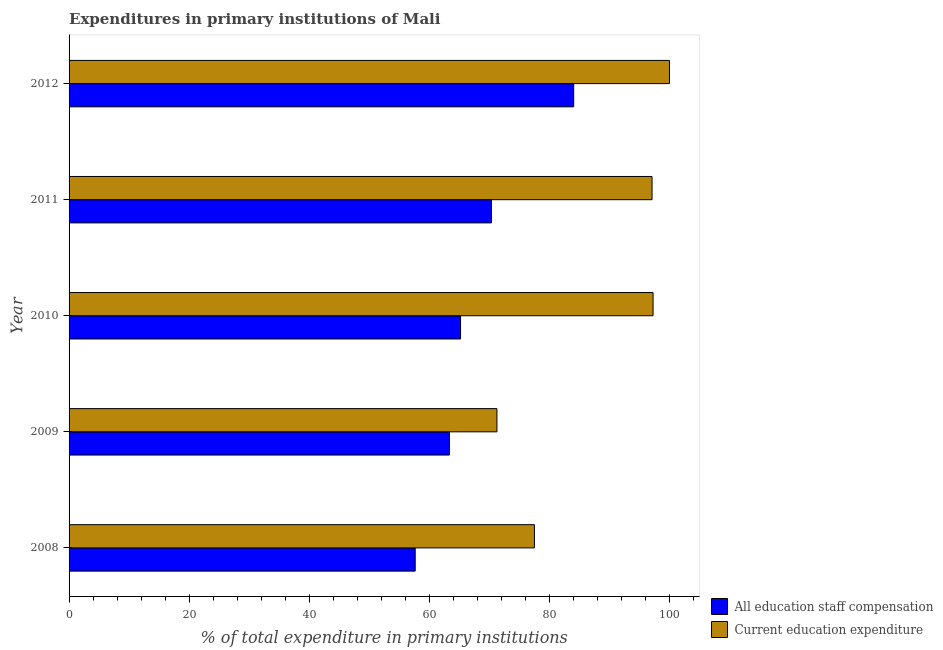How many different coloured bars are there?
Give a very brief answer. 2. How many groups of bars are there?
Ensure brevity in your answer.  5. Are the number of bars per tick equal to the number of legend labels?
Your answer should be compact. Yes. How many bars are there on the 4th tick from the top?
Give a very brief answer. 2. What is the label of the 4th group of bars from the top?
Provide a succinct answer. 2009. What is the expenditure in staff compensation in 2012?
Offer a terse response. 84.04. Across all years, what is the maximum expenditure in staff compensation?
Make the answer very short. 84.04. Across all years, what is the minimum expenditure in education?
Provide a short and direct response. 71.26. In which year was the expenditure in education maximum?
Your answer should be very brief. 2012. In which year was the expenditure in staff compensation minimum?
Provide a succinct answer. 2008. What is the total expenditure in education in the graph?
Make the answer very short. 443.12. What is the difference between the expenditure in education in 2009 and that in 2012?
Provide a short and direct response. -28.74. What is the difference between the expenditure in education in 2012 and the expenditure in staff compensation in 2010?
Your response must be concise. 34.8. What is the average expenditure in education per year?
Make the answer very short. 88.62. In the year 2010, what is the difference between the expenditure in education and expenditure in staff compensation?
Your answer should be very brief. 32.06. In how many years, is the expenditure in staff compensation greater than 28 %?
Offer a terse response. 5. What is the ratio of the expenditure in education in 2008 to that in 2009?
Your answer should be very brief. 1.09. Is the difference between the expenditure in staff compensation in 2010 and 2011 greater than the difference between the expenditure in education in 2010 and 2011?
Your response must be concise. No. What is the difference between the highest and the second highest expenditure in education?
Offer a very short reply. 2.74. What is the difference between the highest and the lowest expenditure in education?
Ensure brevity in your answer.  28.74. Is the sum of the expenditure in education in 2008 and 2009 greater than the maximum expenditure in staff compensation across all years?
Offer a very short reply. Yes. What does the 2nd bar from the top in 2012 represents?
Make the answer very short. All education staff compensation. What does the 2nd bar from the bottom in 2012 represents?
Offer a very short reply. Current education expenditure. What is the difference between two consecutive major ticks on the X-axis?
Make the answer very short. 20. Are the values on the major ticks of X-axis written in scientific E-notation?
Make the answer very short. No. How are the legend labels stacked?
Your answer should be compact. Vertical. What is the title of the graph?
Make the answer very short. Expenditures in primary institutions of Mali. Does "Female" appear as one of the legend labels in the graph?
Your response must be concise. No. What is the label or title of the X-axis?
Your answer should be very brief. % of total expenditure in primary institutions. What is the label or title of the Y-axis?
Make the answer very short. Year. What is the % of total expenditure in primary institutions of All education staff compensation in 2008?
Offer a very short reply. 57.65. What is the % of total expenditure in primary institutions in Current education expenditure in 2008?
Your answer should be compact. 77.51. What is the % of total expenditure in primary institutions of All education staff compensation in 2009?
Give a very brief answer. 63.35. What is the % of total expenditure in primary institutions of Current education expenditure in 2009?
Provide a short and direct response. 71.26. What is the % of total expenditure in primary institutions in All education staff compensation in 2010?
Your answer should be compact. 65.2. What is the % of total expenditure in primary institutions of Current education expenditure in 2010?
Keep it short and to the point. 97.26. What is the % of total expenditure in primary institutions in All education staff compensation in 2011?
Offer a very short reply. 70.35. What is the % of total expenditure in primary institutions in Current education expenditure in 2011?
Your response must be concise. 97.09. What is the % of total expenditure in primary institutions of All education staff compensation in 2012?
Your response must be concise. 84.04. What is the % of total expenditure in primary institutions of Current education expenditure in 2012?
Make the answer very short. 100. Across all years, what is the maximum % of total expenditure in primary institutions of All education staff compensation?
Provide a succinct answer. 84.04. Across all years, what is the minimum % of total expenditure in primary institutions of All education staff compensation?
Offer a very short reply. 57.65. Across all years, what is the minimum % of total expenditure in primary institutions in Current education expenditure?
Offer a very short reply. 71.26. What is the total % of total expenditure in primary institutions in All education staff compensation in the graph?
Ensure brevity in your answer.  340.58. What is the total % of total expenditure in primary institutions of Current education expenditure in the graph?
Keep it short and to the point. 443.12. What is the difference between the % of total expenditure in primary institutions in All education staff compensation in 2008 and that in 2009?
Keep it short and to the point. -5.7. What is the difference between the % of total expenditure in primary institutions in Current education expenditure in 2008 and that in 2009?
Give a very brief answer. 6.25. What is the difference between the % of total expenditure in primary institutions in All education staff compensation in 2008 and that in 2010?
Make the answer very short. -7.55. What is the difference between the % of total expenditure in primary institutions in Current education expenditure in 2008 and that in 2010?
Your response must be concise. -19.76. What is the difference between the % of total expenditure in primary institutions of All education staff compensation in 2008 and that in 2011?
Provide a short and direct response. -12.7. What is the difference between the % of total expenditure in primary institutions in Current education expenditure in 2008 and that in 2011?
Ensure brevity in your answer.  -19.59. What is the difference between the % of total expenditure in primary institutions in All education staff compensation in 2008 and that in 2012?
Your answer should be very brief. -26.39. What is the difference between the % of total expenditure in primary institutions in Current education expenditure in 2008 and that in 2012?
Make the answer very short. -22.49. What is the difference between the % of total expenditure in primary institutions of All education staff compensation in 2009 and that in 2010?
Your answer should be compact. -1.85. What is the difference between the % of total expenditure in primary institutions in Current education expenditure in 2009 and that in 2010?
Offer a very short reply. -26. What is the difference between the % of total expenditure in primary institutions in All education staff compensation in 2009 and that in 2011?
Your answer should be very brief. -7. What is the difference between the % of total expenditure in primary institutions of Current education expenditure in 2009 and that in 2011?
Ensure brevity in your answer.  -25.83. What is the difference between the % of total expenditure in primary institutions in All education staff compensation in 2009 and that in 2012?
Give a very brief answer. -20.69. What is the difference between the % of total expenditure in primary institutions in Current education expenditure in 2009 and that in 2012?
Your response must be concise. -28.74. What is the difference between the % of total expenditure in primary institutions in All education staff compensation in 2010 and that in 2011?
Ensure brevity in your answer.  -5.15. What is the difference between the % of total expenditure in primary institutions in Current education expenditure in 2010 and that in 2011?
Your response must be concise. 0.17. What is the difference between the % of total expenditure in primary institutions in All education staff compensation in 2010 and that in 2012?
Provide a short and direct response. -18.84. What is the difference between the % of total expenditure in primary institutions in Current education expenditure in 2010 and that in 2012?
Your response must be concise. -2.74. What is the difference between the % of total expenditure in primary institutions of All education staff compensation in 2011 and that in 2012?
Provide a short and direct response. -13.69. What is the difference between the % of total expenditure in primary institutions of Current education expenditure in 2011 and that in 2012?
Offer a very short reply. -2.91. What is the difference between the % of total expenditure in primary institutions in All education staff compensation in 2008 and the % of total expenditure in primary institutions in Current education expenditure in 2009?
Your answer should be compact. -13.61. What is the difference between the % of total expenditure in primary institutions of All education staff compensation in 2008 and the % of total expenditure in primary institutions of Current education expenditure in 2010?
Your answer should be compact. -39.61. What is the difference between the % of total expenditure in primary institutions in All education staff compensation in 2008 and the % of total expenditure in primary institutions in Current education expenditure in 2011?
Ensure brevity in your answer.  -39.44. What is the difference between the % of total expenditure in primary institutions in All education staff compensation in 2008 and the % of total expenditure in primary institutions in Current education expenditure in 2012?
Make the answer very short. -42.35. What is the difference between the % of total expenditure in primary institutions in All education staff compensation in 2009 and the % of total expenditure in primary institutions in Current education expenditure in 2010?
Ensure brevity in your answer.  -33.92. What is the difference between the % of total expenditure in primary institutions in All education staff compensation in 2009 and the % of total expenditure in primary institutions in Current education expenditure in 2011?
Offer a very short reply. -33.75. What is the difference between the % of total expenditure in primary institutions in All education staff compensation in 2009 and the % of total expenditure in primary institutions in Current education expenditure in 2012?
Offer a very short reply. -36.65. What is the difference between the % of total expenditure in primary institutions of All education staff compensation in 2010 and the % of total expenditure in primary institutions of Current education expenditure in 2011?
Ensure brevity in your answer.  -31.89. What is the difference between the % of total expenditure in primary institutions of All education staff compensation in 2010 and the % of total expenditure in primary institutions of Current education expenditure in 2012?
Your response must be concise. -34.8. What is the difference between the % of total expenditure in primary institutions of All education staff compensation in 2011 and the % of total expenditure in primary institutions of Current education expenditure in 2012?
Your answer should be compact. -29.65. What is the average % of total expenditure in primary institutions of All education staff compensation per year?
Your answer should be very brief. 68.12. What is the average % of total expenditure in primary institutions of Current education expenditure per year?
Your answer should be compact. 88.62. In the year 2008, what is the difference between the % of total expenditure in primary institutions in All education staff compensation and % of total expenditure in primary institutions in Current education expenditure?
Keep it short and to the point. -19.86. In the year 2009, what is the difference between the % of total expenditure in primary institutions in All education staff compensation and % of total expenditure in primary institutions in Current education expenditure?
Your answer should be compact. -7.91. In the year 2010, what is the difference between the % of total expenditure in primary institutions in All education staff compensation and % of total expenditure in primary institutions in Current education expenditure?
Make the answer very short. -32.06. In the year 2011, what is the difference between the % of total expenditure in primary institutions of All education staff compensation and % of total expenditure in primary institutions of Current education expenditure?
Make the answer very short. -26.75. In the year 2012, what is the difference between the % of total expenditure in primary institutions of All education staff compensation and % of total expenditure in primary institutions of Current education expenditure?
Offer a terse response. -15.96. What is the ratio of the % of total expenditure in primary institutions in All education staff compensation in 2008 to that in 2009?
Provide a succinct answer. 0.91. What is the ratio of the % of total expenditure in primary institutions in Current education expenditure in 2008 to that in 2009?
Your answer should be compact. 1.09. What is the ratio of the % of total expenditure in primary institutions in All education staff compensation in 2008 to that in 2010?
Your response must be concise. 0.88. What is the ratio of the % of total expenditure in primary institutions of Current education expenditure in 2008 to that in 2010?
Provide a succinct answer. 0.8. What is the ratio of the % of total expenditure in primary institutions in All education staff compensation in 2008 to that in 2011?
Ensure brevity in your answer.  0.82. What is the ratio of the % of total expenditure in primary institutions of Current education expenditure in 2008 to that in 2011?
Keep it short and to the point. 0.8. What is the ratio of the % of total expenditure in primary institutions in All education staff compensation in 2008 to that in 2012?
Give a very brief answer. 0.69. What is the ratio of the % of total expenditure in primary institutions in Current education expenditure in 2008 to that in 2012?
Offer a terse response. 0.78. What is the ratio of the % of total expenditure in primary institutions in All education staff compensation in 2009 to that in 2010?
Your response must be concise. 0.97. What is the ratio of the % of total expenditure in primary institutions in Current education expenditure in 2009 to that in 2010?
Give a very brief answer. 0.73. What is the ratio of the % of total expenditure in primary institutions in All education staff compensation in 2009 to that in 2011?
Offer a very short reply. 0.9. What is the ratio of the % of total expenditure in primary institutions in Current education expenditure in 2009 to that in 2011?
Your response must be concise. 0.73. What is the ratio of the % of total expenditure in primary institutions of All education staff compensation in 2009 to that in 2012?
Keep it short and to the point. 0.75. What is the ratio of the % of total expenditure in primary institutions of Current education expenditure in 2009 to that in 2012?
Your response must be concise. 0.71. What is the ratio of the % of total expenditure in primary institutions in All education staff compensation in 2010 to that in 2011?
Offer a terse response. 0.93. What is the ratio of the % of total expenditure in primary institutions of Current education expenditure in 2010 to that in 2011?
Your answer should be compact. 1. What is the ratio of the % of total expenditure in primary institutions of All education staff compensation in 2010 to that in 2012?
Provide a succinct answer. 0.78. What is the ratio of the % of total expenditure in primary institutions in Current education expenditure in 2010 to that in 2012?
Ensure brevity in your answer.  0.97. What is the ratio of the % of total expenditure in primary institutions of All education staff compensation in 2011 to that in 2012?
Provide a short and direct response. 0.84. What is the ratio of the % of total expenditure in primary institutions of Current education expenditure in 2011 to that in 2012?
Ensure brevity in your answer.  0.97. What is the difference between the highest and the second highest % of total expenditure in primary institutions in All education staff compensation?
Provide a succinct answer. 13.69. What is the difference between the highest and the second highest % of total expenditure in primary institutions in Current education expenditure?
Ensure brevity in your answer.  2.74. What is the difference between the highest and the lowest % of total expenditure in primary institutions in All education staff compensation?
Provide a short and direct response. 26.39. What is the difference between the highest and the lowest % of total expenditure in primary institutions of Current education expenditure?
Give a very brief answer. 28.74. 